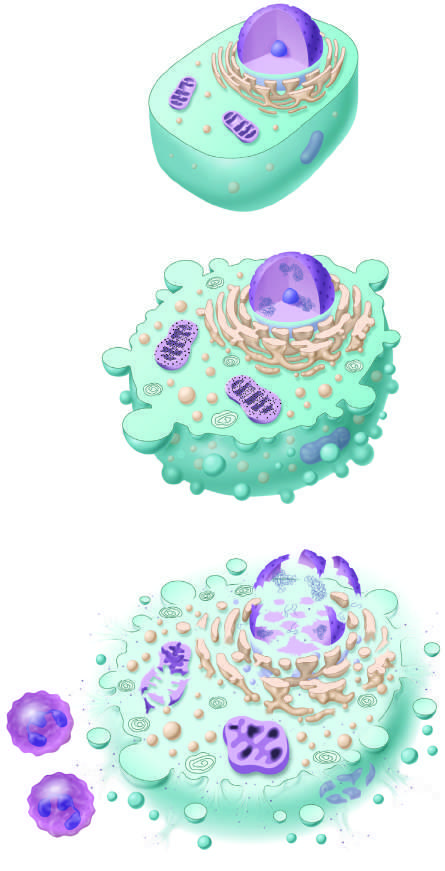re the principal cellular alterations that characterize reversible cell injury and necrosis illustrated?
Answer the question using a single word or phrase. Yes 